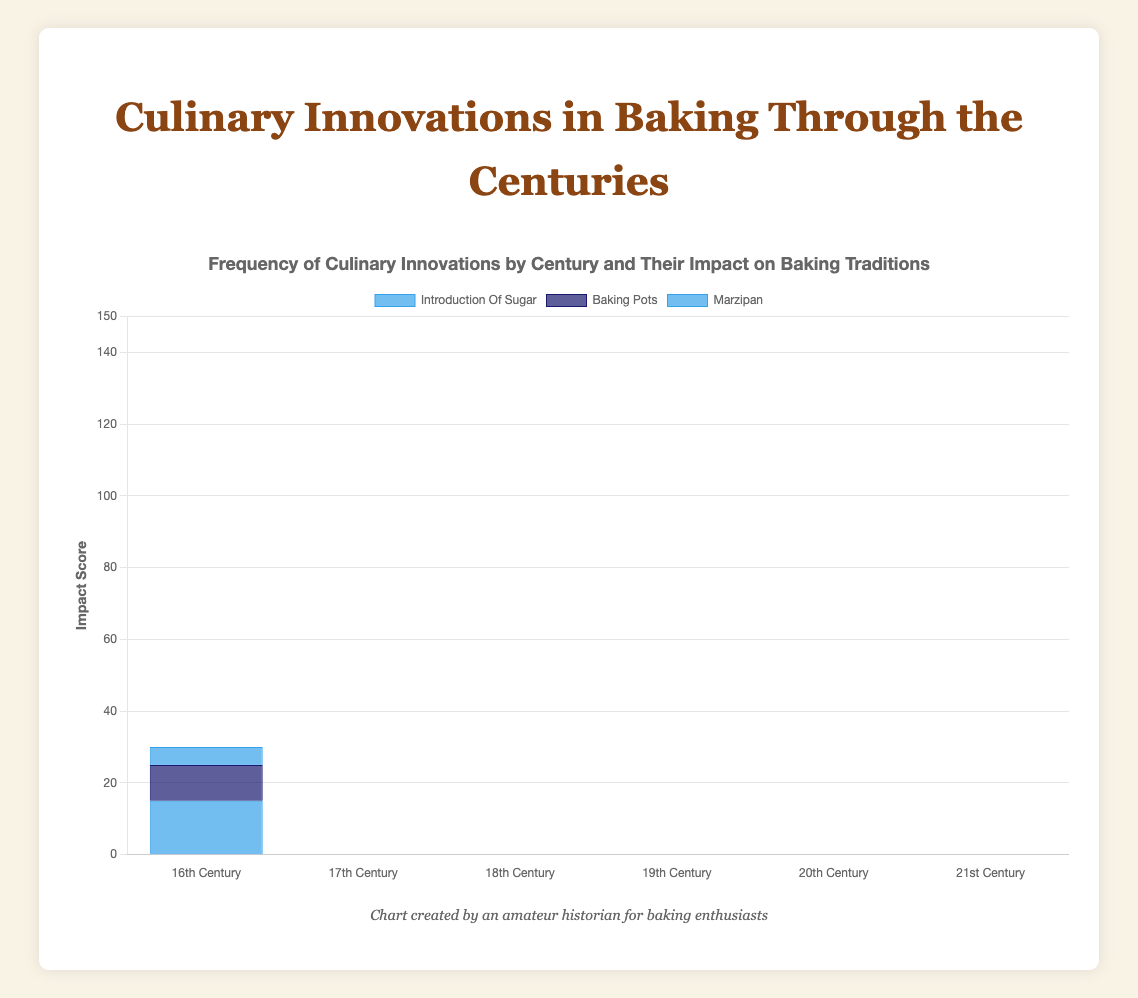What was the most impactful culinary innovation in the 21st Century? The highest bar in the 21st Century category represents the most impactful innovation. The tallest bar is for "3D printed cakes" with a score of 50.
Answer: 3D printed cakes Which century introduced more impactful innovations: the 19th Century or the 20th Century? Sum the impact scores for each innovation in both centuries. For the 19th Century, it's (30 + 25 + 20) = 75. For the 20th Century, it's (40 + 35 + 30) = 105.
Answer: 20th Century In which century did "sponge cakes" and "icing and frosting" innovations cumulatively have the highest impact? They were introduced in the 17th Century and have impacts of 20 and 15 respectively. The sum is 20 + 15 = 35. Check the sum for each century to confirm.
Answer: 17th Century What is the average impact score of culinary innovations in the 18th Century? Add the scores for "layered cakes" (25), "buttercream" (20), and "baking powder" (10). The total is 55. Dividing by the number of innovations, 55/3.
Answer: 18.33 Which innovation has the lowest impact score in the 16th Century? Comparing the bars in the 16th Century category, "marzipan" has the lowest score with an impact of 5.
Answer: Marzipan How does the impact of "electric mixers" in the 20th Century compare to "baking soda" in the 19th Century? "Electric mixers" in the 20th Century have an impact of 40, while "baking soda" in the 19th Century has an impact of 25. 40 > 25.
Answer: Electric mixers Did any century have an equal total impact score for more than two culinary innovations? Calculate total impact for two innovations per century: none of the centuries show the same total impact score for two innovations.
Answer: No What is the cumulative difference between the impacts of "3D printed cakes" and "gluten-free baking" in the 21st Century? The impact of "3D printed cakes" is 50 and "gluten-free baking" is 45. The difference is 50 - 45 = 5.
Answer: 5 What were the most common innovation categories introduced in the 19th and 21st Centuries and how do they compare in total impact? For the 19th Century, the highest impact is "chocolate cakes" (30), "baking soda" (25), and "custard and pudding" (20). For the 21st Century, "3D printed cakes" (50), "gluten-free baking" (45), "vegan baking" (40). 75 vs. 135.
Answer: The 21st Century with 135 How many centuries have at least one innovation with an impact score higher than 25? Check each century: 19th (30, 25), 20th (40, 35, 30), 21st (50, 45, 40). Total: 19th, 20th, and 21st centuries.
Answer: 3 